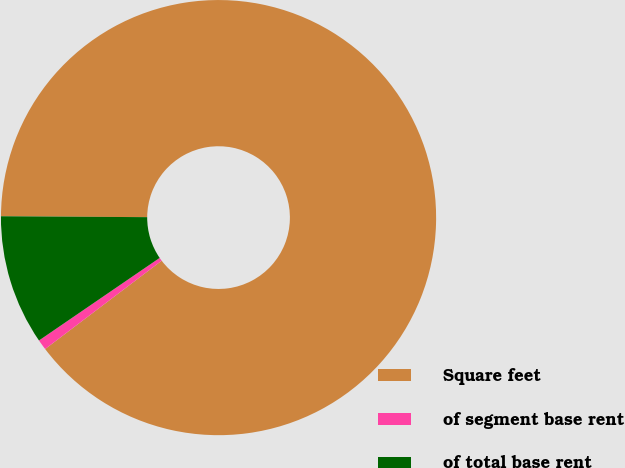Convert chart to OTSL. <chart><loc_0><loc_0><loc_500><loc_500><pie_chart><fcel>Square feet<fcel>of segment base rent<fcel>of total base rent<nl><fcel>89.58%<fcel>0.77%<fcel>9.65%<nl></chart> 